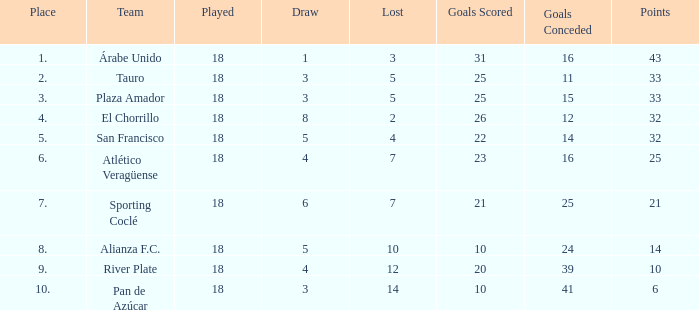How many points did the team have that conceded 41 goals and finish in a place larger than 10? 0.0. 